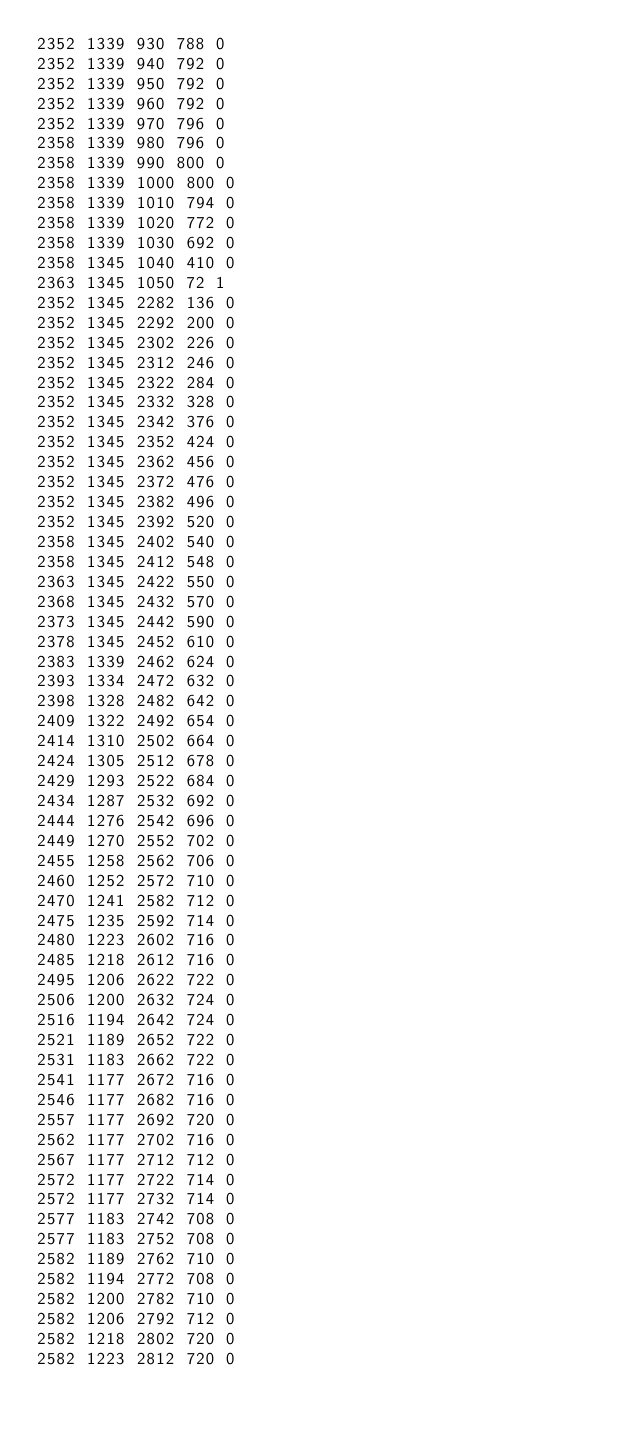<code> <loc_0><loc_0><loc_500><loc_500><_SML_>2352 1339 930 788 0
2352 1339 940 792 0
2352 1339 950 792 0
2352 1339 960 792 0
2352 1339 970 796 0
2358 1339 980 796 0
2358 1339 990 800 0
2358 1339 1000 800 0
2358 1339 1010 794 0
2358 1339 1020 772 0
2358 1339 1030 692 0
2358 1345 1040 410 0
2363 1345 1050 72 1
2352 1345 2282 136 0
2352 1345 2292 200 0
2352 1345 2302 226 0
2352 1345 2312 246 0
2352 1345 2322 284 0
2352 1345 2332 328 0
2352 1345 2342 376 0
2352 1345 2352 424 0
2352 1345 2362 456 0
2352 1345 2372 476 0
2352 1345 2382 496 0
2352 1345 2392 520 0
2358 1345 2402 540 0
2358 1345 2412 548 0
2363 1345 2422 550 0
2368 1345 2432 570 0
2373 1345 2442 590 0
2378 1345 2452 610 0
2383 1339 2462 624 0
2393 1334 2472 632 0
2398 1328 2482 642 0
2409 1322 2492 654 0
2414 1310 2502 664 0
2424 1305 2512 678 0
2429 1293 2522 684 0
2434 1287 2532 692 0
2444 1276 2542 696 0
2449 1270 2552 702 0
2455 1258 2562 706 0
2460 1252 2572 710 0
2470 1241 2582 712 0
2475 1235 2592 714 0
2480 1223 2602 716 0
2485 1218 2612 716 0
2495 1206 2622 722 0
2506 1200 2632 724 0
2516 1194 2642 724 0
2521 1189 2652 722 0
2531 1183 2662 722 0
2541 1177 2672 716 0
2546 1177 2682 716 0
2557 1177 2692 720 0
2562 1177 2702 716 0
2567 1177 2712 712 0
2572 1177 2722 714 0
2572 1177 2732 714 0
2577 1183 2742 708 0
2577 1183 2752 708 0
2582 1189 2762 710 0
2582 1194 2772 708 0
2582 1200 2782 710 0
2582 1206 2792 712 0
2582 1218 2802 720 0
2582 1223 2812 720 0</code> 